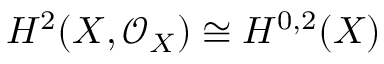<formula> <loc_0><loc_0><loc_500><loc_500>H ^ { 2 } ( X , { \mathcal { O } } _ { X } ) \cong H ^ { 0 , 2 } ( X )</formula> 